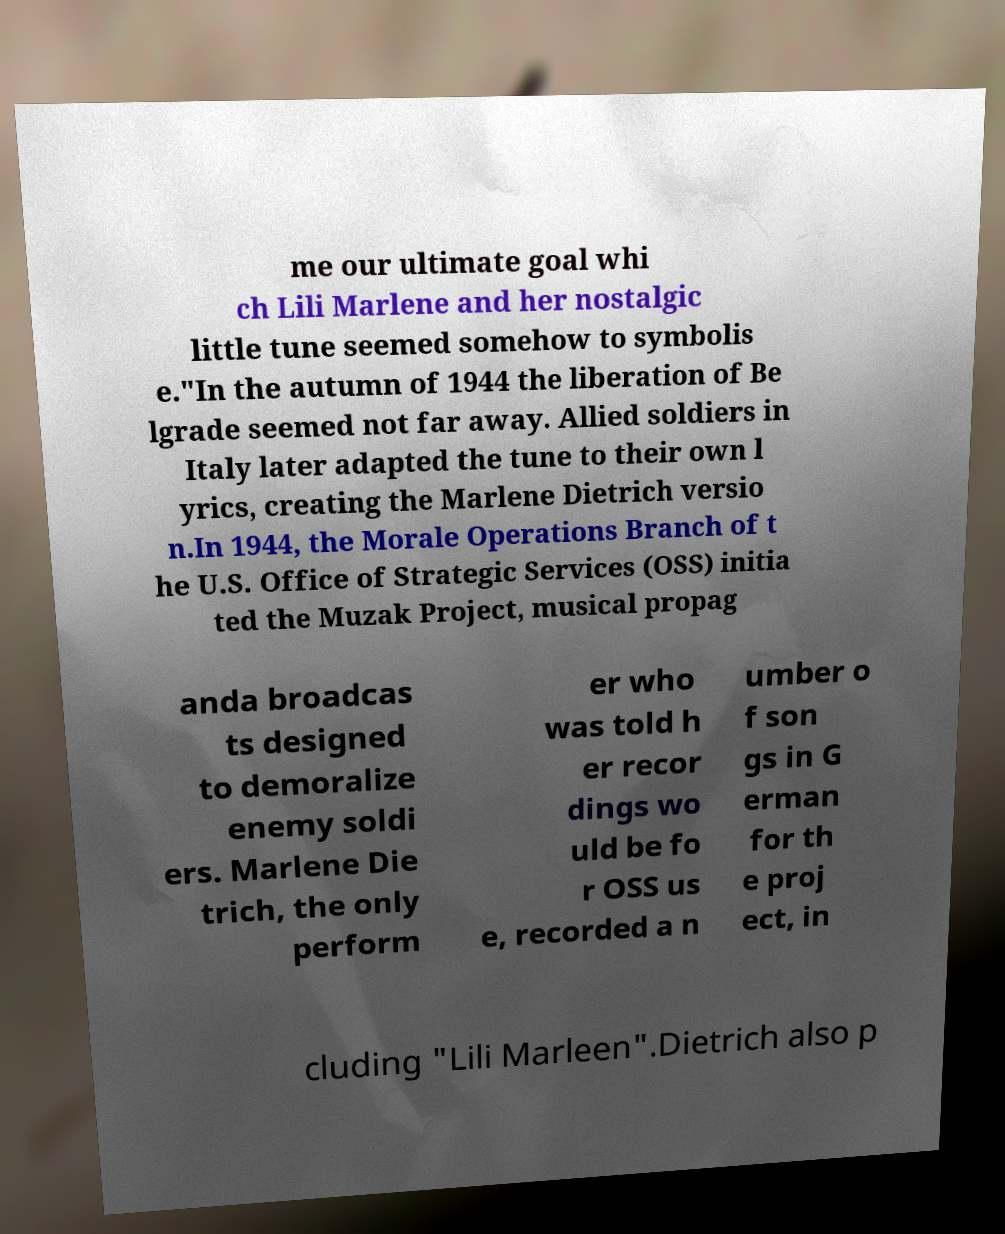Please read and relay the text visible in this image. What does it say? me our ultimate goal whi ch Lili Marlene and her nostalgic little tune seemed somehow to symbolis e."In the autumn of 1944 the liberation of Be lgrade seemed not far away. Allied soldiers in Italy later adapted the tune to their own l yrics, creating the Marlene Dietrich versio n.In 1944, the Morale Operations Branch of t he U.S. Office of Strategic Services (OSS) initia ted the Muzak Project, musical propag anda broadcas ts designed to demoralize enemy soldi ers. Marlene Die trich, the only perform er who was told h er recor dings wo uld be fo r OSS us e, recorded a n umber o f son gs in G erman for th e proj ect, in cluding "Lili Marleen".Dietrich also p 